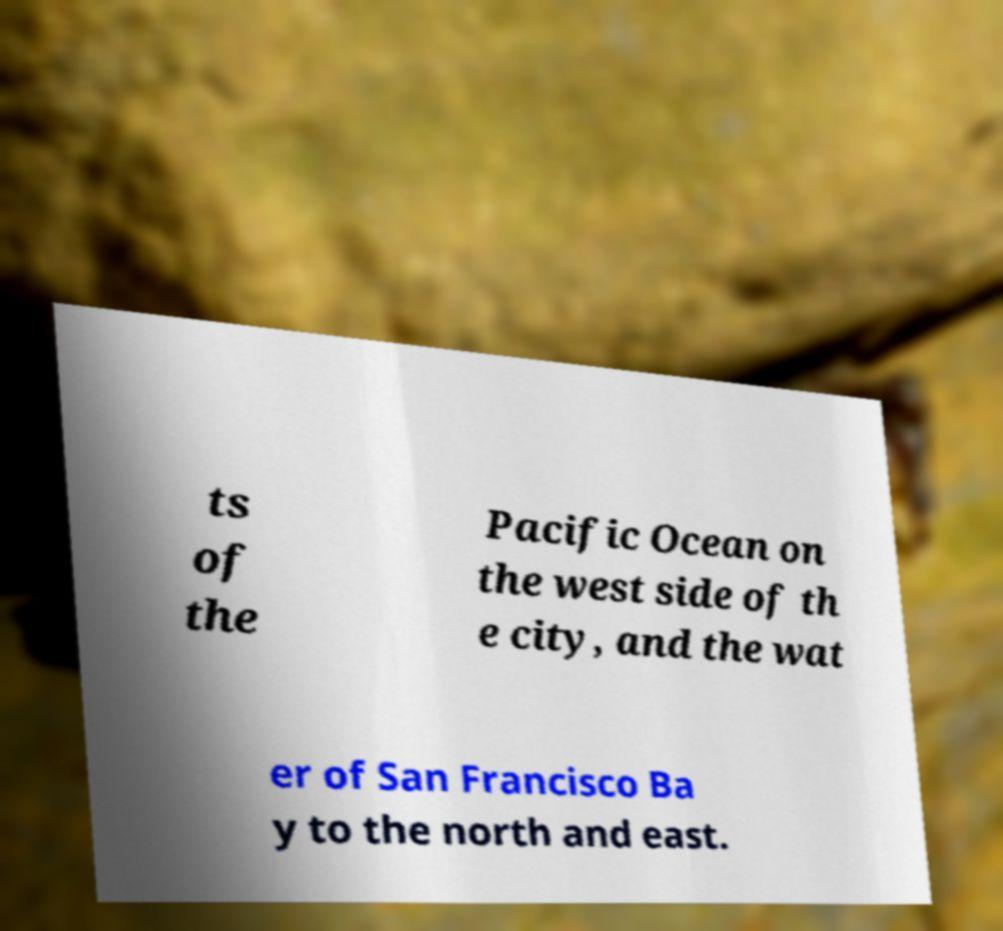Please identify and transcribe the text found in this image. ts of the Pacific Ocean on the west side of th e city, and the wat er of San Francisco Ba y to the north and east. 